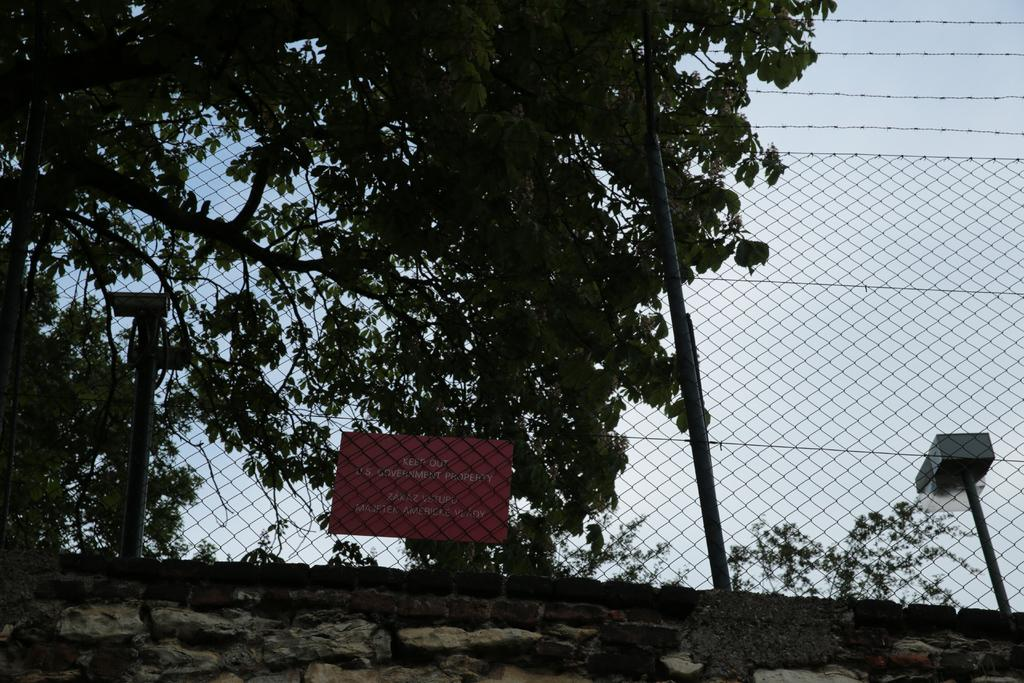What is the primary material in the image? There is a mesh in the image. What other structures can be seen in the image? There are poles in the image. What can be seen through the mesh? Trees, plants, a name board, and the sky can be seen through the mesh. What is at the bottom of the image? There is a stone wall at the bottom of the image. What type of celery is being used to cough into the mouth in the image? There is no celery, coughing, or mouth present in the image. 